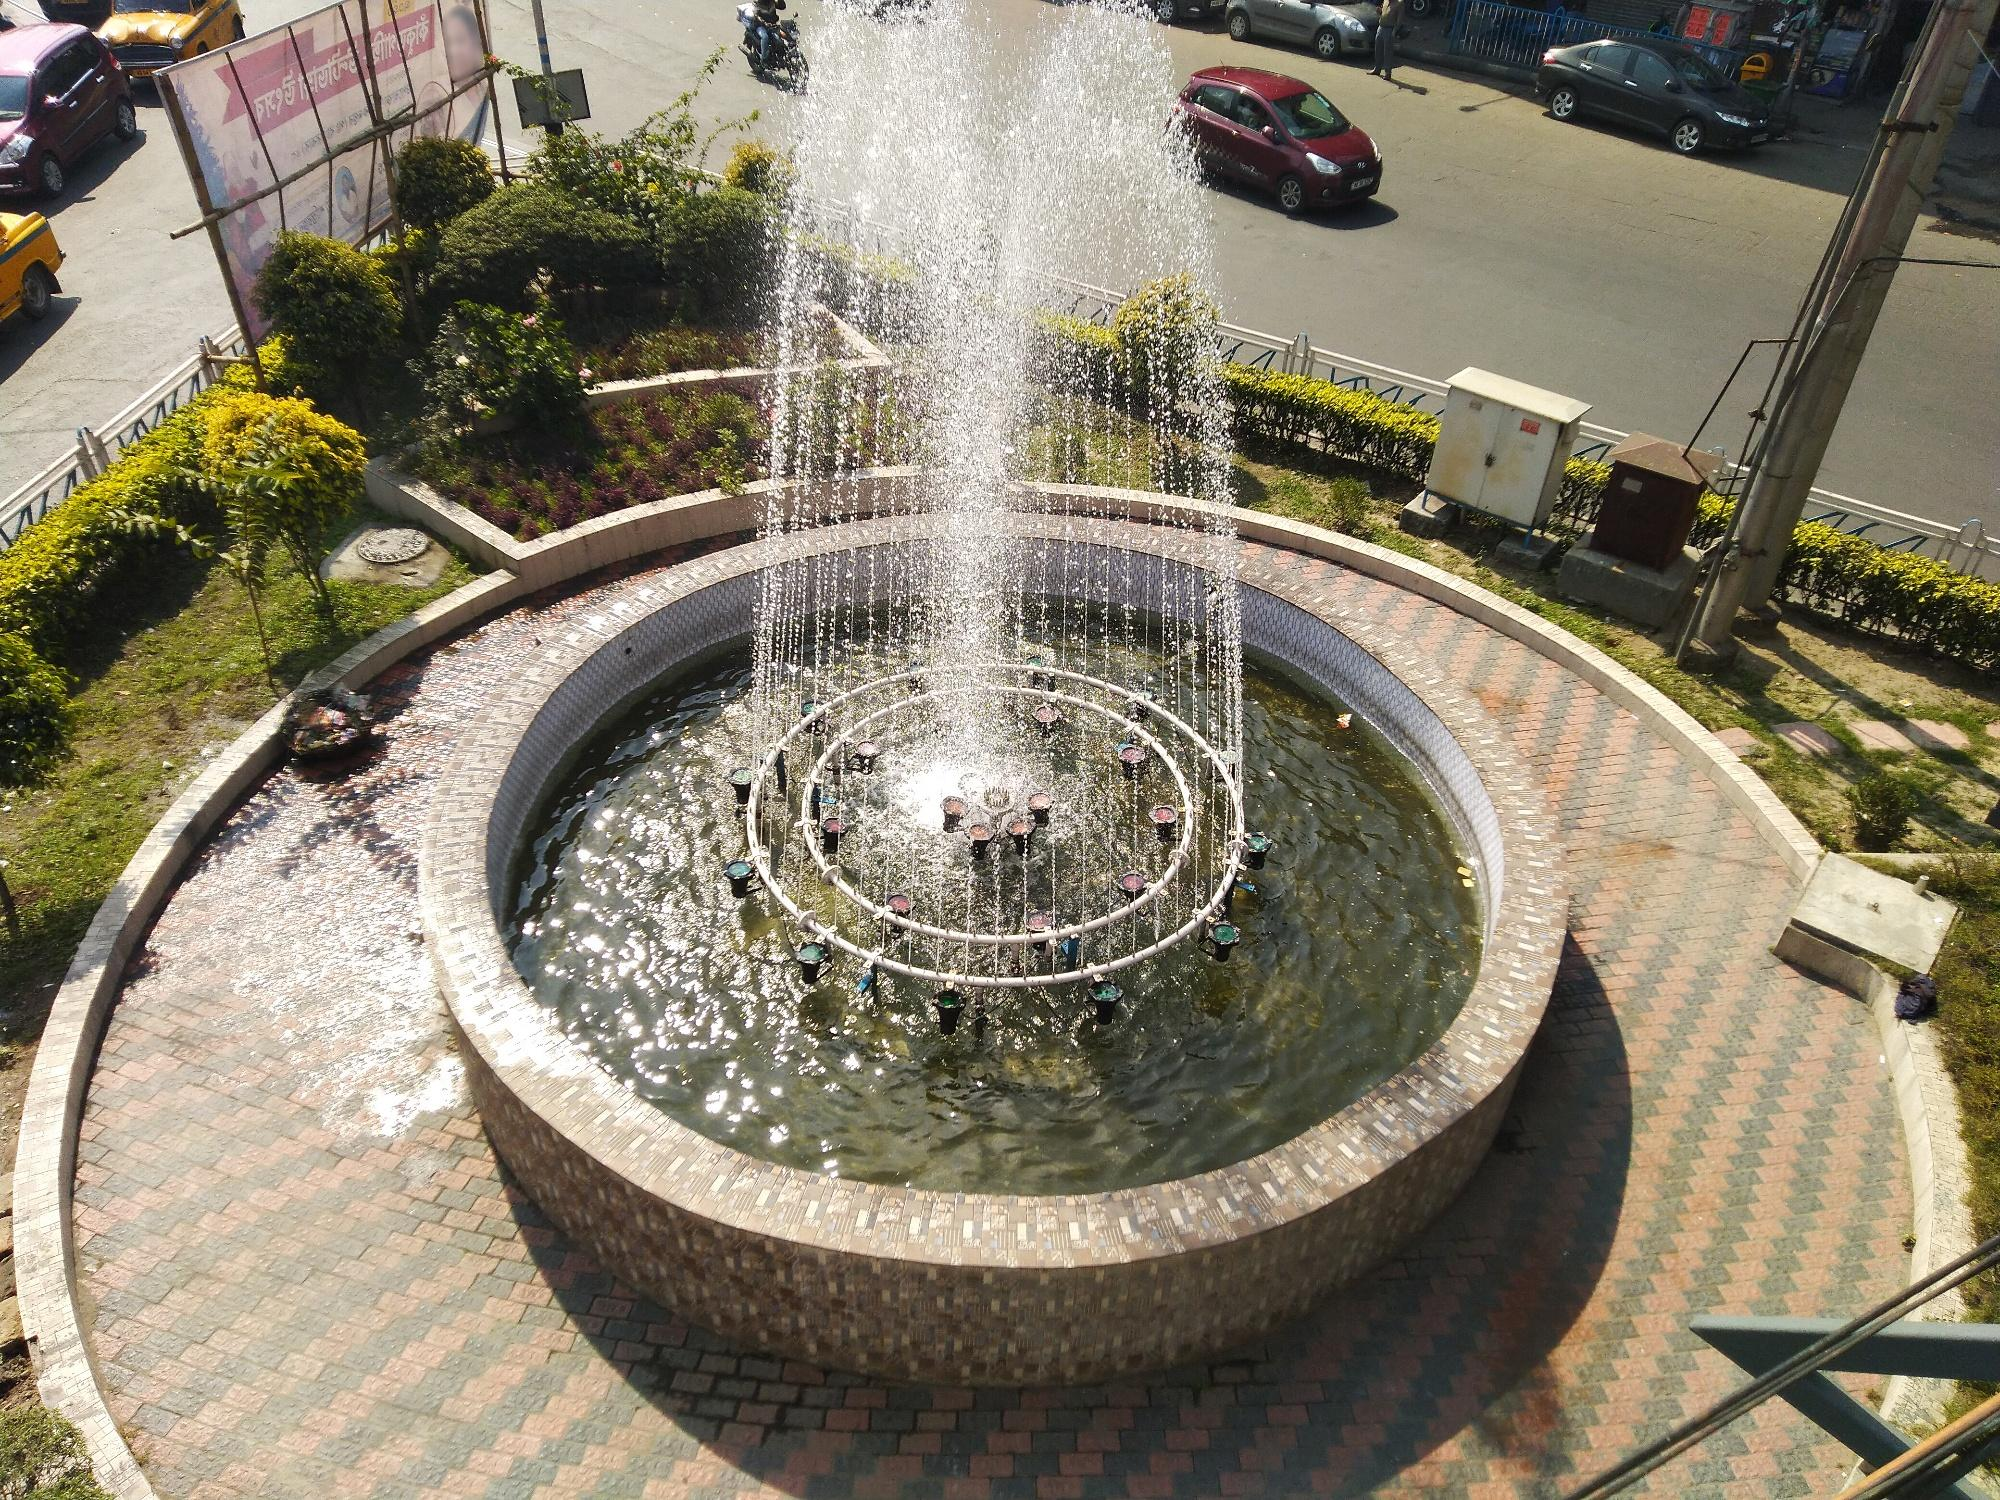Predict how the fountain area will look like in 50 years. In 50 years, this fountain area might transform into a high-tech urban oasis. Smart lighting could be integrated to illuminate the water jets in various colors, synchronized with music. The walkway could be made from eco-friendly materials, equipped with solar panels generating power for the lights and nearby amenities. Surrounding buildings might have vertical gardens providing lush greenery. Autonomous vehicles would silently navigate the roundabout, and the entire area might be monitored by advanced systems ensuring cleanliness and maintenance, creating a futuristic yet inviting public space. 